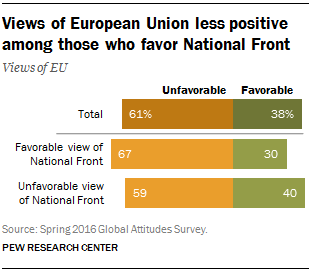Mention a couple of crucial points in this snapshot. The color of favorable bars is not orange. 